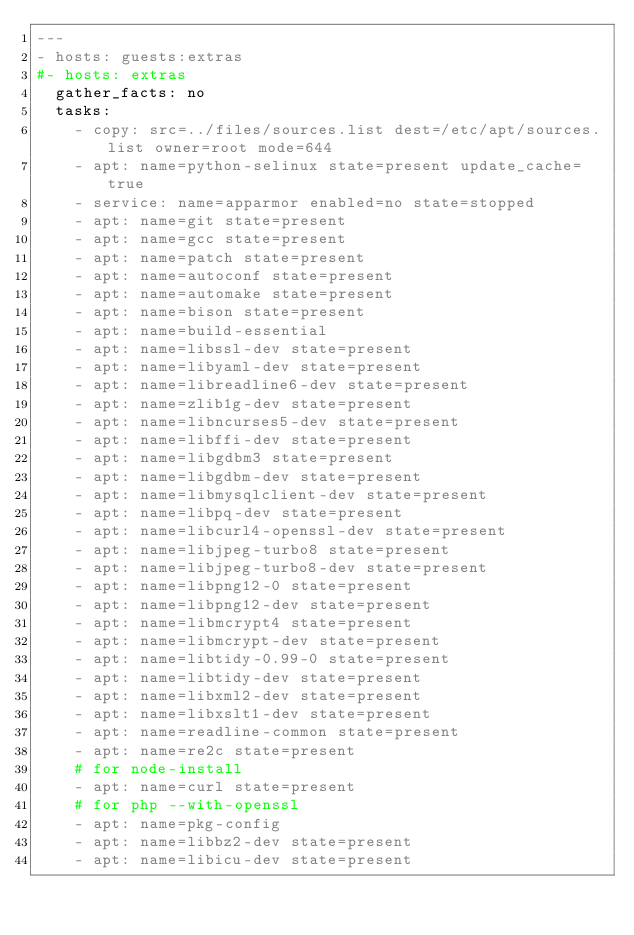Convert code to text. <code><loc_0><loc_0><loc_500><loc_500><_YAML_>---
- hosts: guests:extras
#- hosts: extras
  gather_facts: no
  tasks:
    - copy: src=../files/sources.list dest=/etc/apt/sources.list owner=root mode=644
    - apt: name=python-selinux state=present update_cache=true
    - service: name=apparmor enabled=no state=stopped
    - apt: name=git state=present
    - apt: name=gcc state=present
    - apt: name=patch state=present
    - apt: name=autoconf state=present
    - apt: name=automake state=present
    - apt: name=bison state=present
    - apt: name=build-essential
    - apt: name=libssl-dev state=present
    - apt: name=libyaml-dev state=present
    - apt: name=libreadline6-dev state=present
    - apt: name=zlib1g-dev state=present
    - apt: name=libncurses5-dev state=present
    - apt: name=libffi-dev state=present
    - apt: name=libgdbm3 state=present
    - apt: name=libgdbm-dev state=present
    - apt: name=libmysqlclient-dev state=present
    - apt: name=libpq-dev state=present
    - apt: name=libcurl4-openssl-dev state=present
    - apt: name=libjpeg-turbo8 state=present
    - apt: name=libjpeg-turbo8-dev state=present
    - apt: name=libpng12-0 state=present
    - apt: name=libpng12-dev state=present
    - apt: name=libmcrypt4 state=present
    - apt: name=libmcrypt-dev state=present
    - apt: name=libtidy-0.99-0 state=present
    - apt: name=libtidy-dev state=present
    - apt: name=libxml2-dev state=present
    - apt: name=libxslt1-dev state=present
    - apt: name=readline-common state=present
    - apt: name=re2c state=present
    # for node-install
    - apt: name=curl state=present
    # for php --with-openssl
    - apt: name=pkg-config
    - apt: name=libbz2-dev state=present
    - apt: name=libicu-dev state=present
</code> 